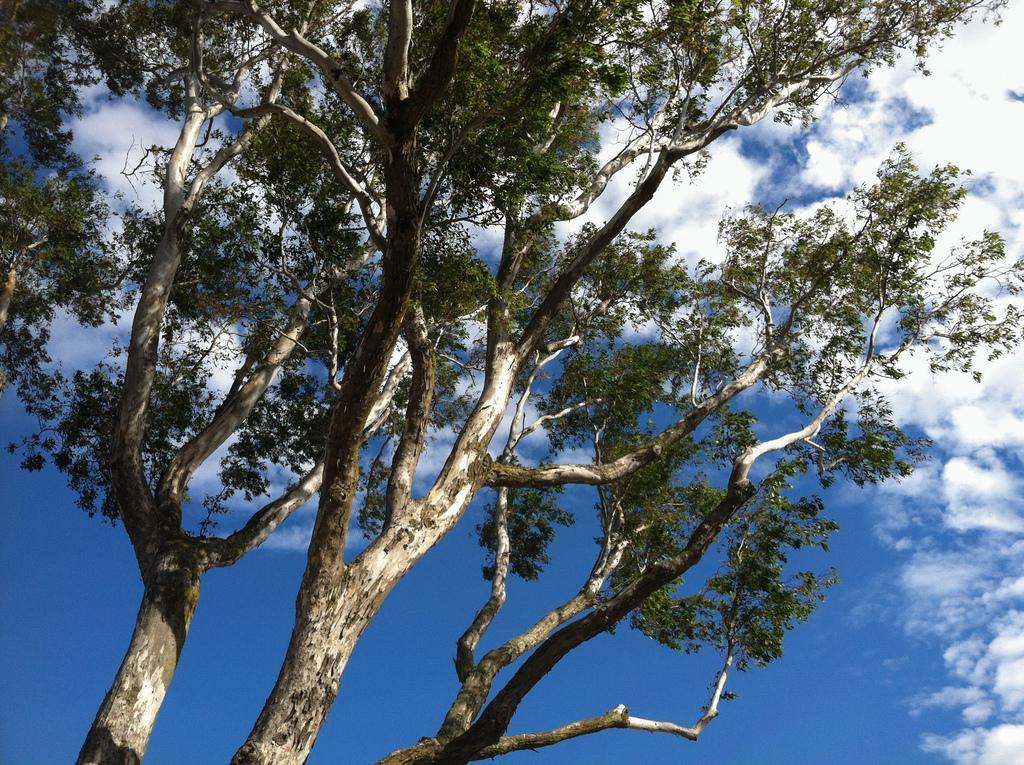Please provide a concise description of this image. In this image, we can see tree, branches, stems and leaves. Background we can see the sky. 